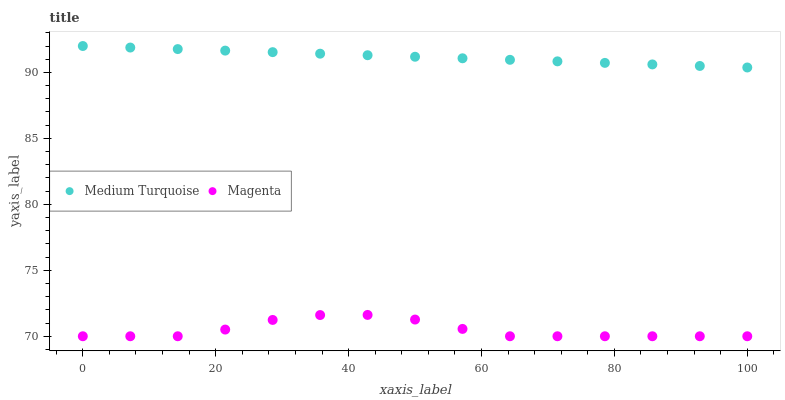Does Magenta have the minimum area under the curve?
Answer yes or no. Yes. Does Medium Turquoise have the maximum area under the curve?
Answer yes or no. Yes. Does Medium Turquoise have the minimum area under the curve?
Answer yes or no. No. Is Medium Turquoise the smoothest?
Answer yes or no. Yes. Is Magenta the roughest?
Answer yes or no. Yes. Is Medium Turquoise the roughest?
Answer yes or no. No. Does Magenta have the lowest value?
Answer yes or no. Yes. Does Medium Turquoise have the lowest value?
Answer yes or no. No. Does Medium Turquoise have the highest value?
Answer yes or no. Yes. Is Magenta less than Medium Turquoise?
Answer yes or no. Yes. Is Medium Turquoise greater than Magenta?
Answer yes or no. Yes. Does Magenta intersect Medium Turquoise?
Answer yes or no. No. 